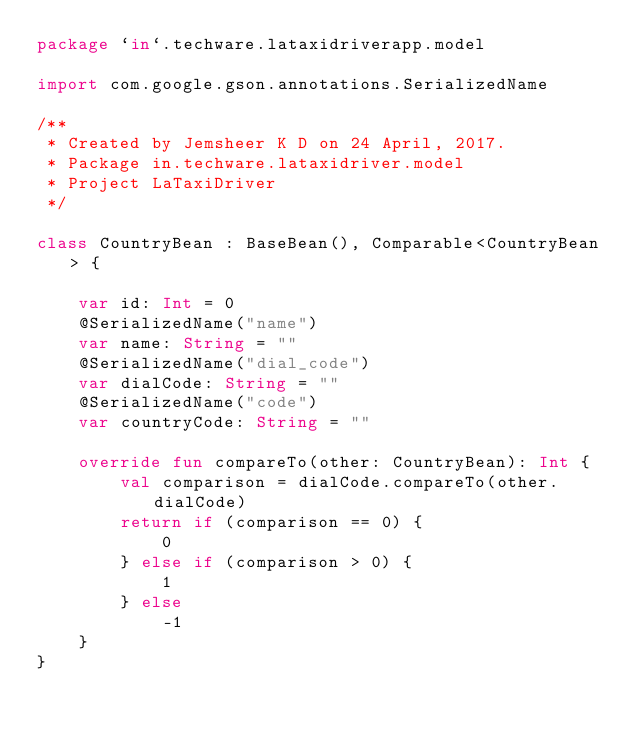<code> <loc_0><loc_0><loc_500><loc_500><_Kotlin_>package `in`.techware.lataxidriverapp.model

import com.google.gson.annotations.SerializedName

/**
 * Created by Jemsheer K D on 24 April, 2017.
 * Package in.techware.lataxidriver.model
 * Project LaTaxiDriver
 */

class CountryBean : BaseBean(), Comparable<CountryBean> {

    var id: Int = 0
    @SerializedName("name")
    var name: String = ""
    @SerializedName("dial_code")
    var dialCode: String = ""
    @SerializedName("code")
    var countryCode: String = ""

    override fun compareTo(other: CountryBean): Int {
        val comparison = dialCode.compareTo(other.dialCode)
        return if (comparison == 0) {
            0
        } else if (comparison > 0) {
            1
        } else
            -1
    }
}
</code> 